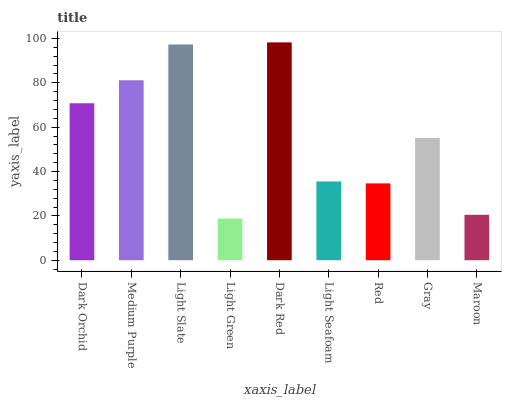Is Light Green the minimum?
Answer yes or no. Yes. Is Dark Red the maximum?
Answer yes or no. Yes. Is Medium Purple the minimum?
Answer yes or no. No. Is Medium Purple the maximum?
Answer yes or no. No. Is Medium Purple greater than Dark Orchid?
Answer yes or no. Yes. Is Dark Orchid less than Medium Purple?
Answer yes or no. Yes. Is Dark Orchid greater than Medium Purple?
Answer yes or no. No. Is Medium Purple less than Dark Orchid?
Answer yes or no. No. Is Gray the high median?
Answer yes or no. Yes. Is Gray the low median?
Answer yes or no. Yes. Is Maroon the high median?
Answer yes or no. No. Is Dark Orchid the low median?
Answer yes or no. No. 